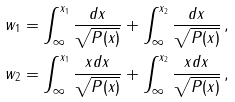Convert formula to latex. <formula><loc_0><loc_0><loc_500><loc_500>w _ { 1 } & = \int _ { \infty } ^ { x _ { 1 } } \frac { d x } { \sqrt { P ( x ) } } + \int _ { \infty } ^ { x _ { 2 } } \frac { d x } { \sqrt { P ( x ) } } \, , \\ w _ { 2 } & = \int _ { \infty } ^ { x _ { 1 } } \frac { x d x } { \sqrt { P ( x ) } } + \int _ { \infty } ^ { x _ { 2 } } \frac { x d x } { \sqrt { P ( x ) } } \, ,</formula> 